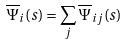Convert formula to latex. <formula><loc_0><loc_0><loc_500><loc_500>\overline { \Psi } _ { i } ( s ) = \sum _ { j } \overline { \Psi } _ { i j } ( s )</formula> 